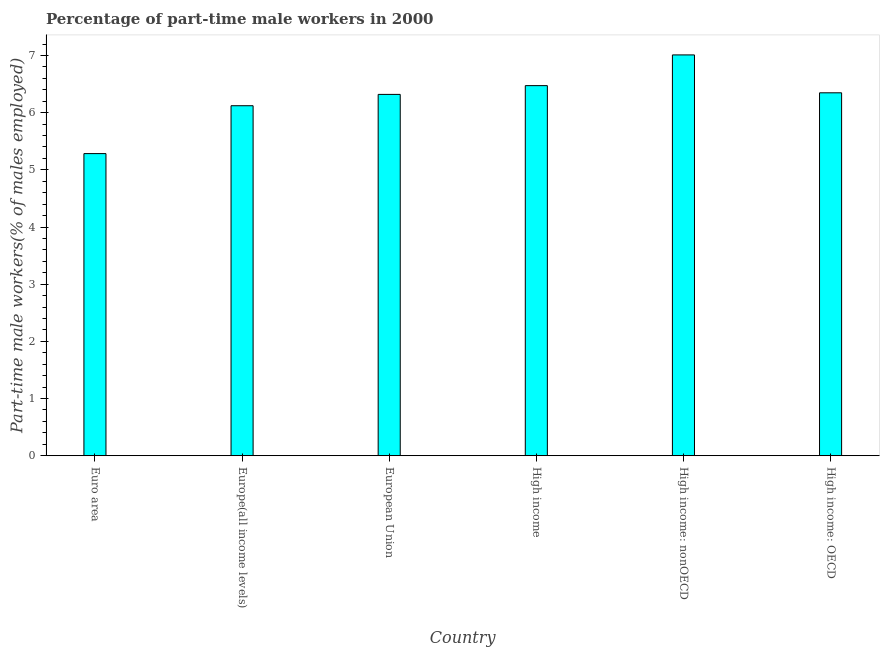Does the graph contain grids?
Give a very brief answer. No. What is the title of the graph?
Your answer should be compact. Percentage of part-time male workers in 2000. What is the label or title of the X-axis?
Provide a succinct answer. Country. What is the label or title of the Y-axis?
Make the answer very short. Part-time male workers(% of males employed). What is the percentage of part-time male workers in Euro area?
Offer a terse response. 5.28. Across all countries, what is the maximum percentage of part-time male workers?
Provide a short and direct response. 7.01. Across all countries, what is the minimum percentage of part-time male workers?
Your answer should be very brief. 5.28. In which country was the percentage of part-time male workers maximum?
Make the answer very short. High income: nonOECD. What is the sum of the percentage of part-time male workers?
Give a very brief answer. 37.56. What is the difference between the percentage of part-time male workers in Europe(all income levels) and European Union?
Offer a terse response. -0.2. What is the average percentage of part-time male workers per country?
Offer a terse response. 6.26. What is the median percentage of part-time male workers?
Your response must be concise. 6.33. What is the ratio of the percentage of part-time male workers in Europe(all income levels) to that in High income: nonOECD?
Make the answer very short. 0.87. Is the difference between the percentage of part-time male workers in Euro area and High income greater than the difference between any two countries?
Your response must be concise. No. What is the difference between the highest and the second highest percentage of part-time male workers?
Provide a succinct answer. 0.54. What is the difference between the highest and the lowest percentage of part-time male workers?
Keep it short and to the point. 1.73. How many countries are there in the graph?
Provide a short and direct response. 6. What is the difference between two consecutive major ticks on the Y-axis?
Provide a short and direct response. 1. What is the Part-time male workers(% of males employed) of Euro area?
Provide a short and direct response. 5.28. What is the Part-time male workers(% of males employed) of Europe(all income levels)?
Your response must be concise. 6.12. What is the Part-time male workers(% of males employed) of European Union?
Offer a terse response. 6.32. What is the Part-time male workers(% of males employed) in High income?
Provide a short and direct response. 6.47. What is the Part-time male workers(% of males employed) of High income: nonOECD?
Provide a short and direct response. 7.01. What is the Part-time male workers(% of males employed) of High income: OECD?
Give a very brief answer. 6.35. What is the difference between the Part-time male workers(% of males employed) in Euro area and Europe(all income levels)?
Ensure brevity in your answer.  -0.84. What is the difference between the Part-time male workers(% of males employed) in Euro area and European Union?
Offer a very short reply. -1.04. What is the difference between the Part-time male workers(% of males employed) in Euro area and High income?
Offer a terse response. -1.19. What is the difference between the Part-time male workers(% of males employed) in Euro area and High income: nonOECD?
Keep it short and to the point. -1.73. What is the difference between the Part-time male workers(% of males employed) in Euro area and High income: OECD?
Make the answer very short. -1.06. What is the difference between the Part-time male workers(% of males employed) in Europe(all income levels) and European Union?
Give a very brief answer. -0.2. What is the difference between the Part-time male workers(% of males employed) in Europe(all income levels) and High income?
Your answer should be very brief. -0.35. What is the difference between the Part-time male workers(% of males employed) in Europe(all income levels) and High income: nonOECD?
Your answer should be compact. -0.89. What is the difference between the Part-time male workers(% of males employed) in Europe(all income levels) and High income: OECD?
Keep it short and to the point. -0.23. What is the difference between the Part-time male workers(% of males employed) in European Union and High income?
Ensure brevity in your answer.  -0.15. What is the difference between the Part-time male workers(% of males employed) in European Union and High income: nonOECD?
Your answer should be very brief. -0.69. What is the difference between the Part-time male workers(% of males employed) in European Union and High income: OECD?
Offer a terse response. -0.03. What is the difference between the Part-time male workers(% of males employed) in High income and High income: nonOECD?
Provide a succinct answer. -0.54. What is the difference between the Part-time male workers(% of males employed) in High income and High income: OECD?
Provide a short and direct response. 0.13. What is the difference between the Part-time male workers(% of males employed) in High income: nonOECD and High income: OECD?
Keep it short and to the point. 0.66. What is the ratio of the Part-time male workers(% of males employed) in Euro area to that in Europe(all income levels)?
Make the answer very short. 0.86. What is the ratio of the Part-time male workers(% of males employed) in Euro area to that in European Union?
Your answer should be compact. 0.84. What is the ratio of the Part-time male workers(% of males employed) in Euro area to that in High income?
Offer a very short reply. 0.82. What is the ratio of the Part-time male workers(% of males employed) in Euro area to that in High income: nonOECD?
Make the answer very short. 0.75. What is the ratio of the Part-time male workers(% of males employed) in Euro area to that in High income: OECD?
Ensure brevity in your answer.  0.83. What is the ratio of the Part-time male workers(% of males employed) in Europe(all income levels) to that in European Union?
Your answer should be compact. 0.97. What is the ratio of the Part-time male workers(% of males employed) in Europe(all income levels) to that in High income?
Your answer should be very brief. 0.95. What is the ratio of the Part-time male workers(% of males employed) in Europe(all income levels) to that in High income: nonOECD?
Ensure brevity in your answer.  0.87. What is the ratio of the Part-time male workers(% of males employed) in Europe(all income levels) to that in High income: OECD?
Make the answer very short. 0.96. What is the ratio of the Part-time male workers(% of males employed) in European Union to that in High income?
Offer a very short reply. 0.98. What is the ratio of the Part-time male workers(% of males employed) in European Union to that in High income: nonOECD?
Offer a very short reply. 0.9. What is the ratio of the Part-time male workers(% of males employed) in High income to that in High income: nonOECD?
Give a very brief answer. 0.92. What is the ratio of the Part-time male workers(% of males employed) in High income to that in High income: OECD?
Provide a short and direct response. 1.02. What is the ratio of the Part-time male workers(% of males employed) in High income: nonOECD to that in High income: OECD?
Ensure brevity in your answer.  1.1. 